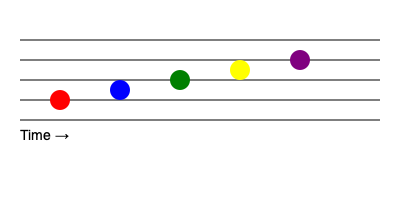Analyze the colorful musical score representation above. If each color represents a unique instrument and the vertical position indicates pitch (higher position = higher pitch), what pattern does this visual score suggest about the melody's progression? To interpret this visual musical score, we need to consider both the horizontal and vertical positions of the colored notes:

1. Horizontal position: The notes are evenly spaced from left to right, indicating a consistent rhythm or tempo. The text "Time →" confirms that the horizontal axis represents time progression.

2. Vertical position: The notes are positioned on different levels of the staff, with higher positions representing higher pitches.

3. Color representation: Each color represents a different instrument, allowing us to track the progression of instruments playing the melody.

4. Pitch progression:
   - The red note (leftmost) is the lowest in pitch.
   - The blue note is slightly higher.
   - The green note is higher than the blue note.
   - The yellow note is higher than the green note.
   - The purple note (rightmost) is the highest in pitch.

5. Overall pattern: As we move from left to right (over time), each subsequent note is higher in pitch than the previous one.

This visual representation suggests that the melody is ascending in pitch over time, with each instrument playing a progressively higher note in sequence.
Answer: Ascending melody 